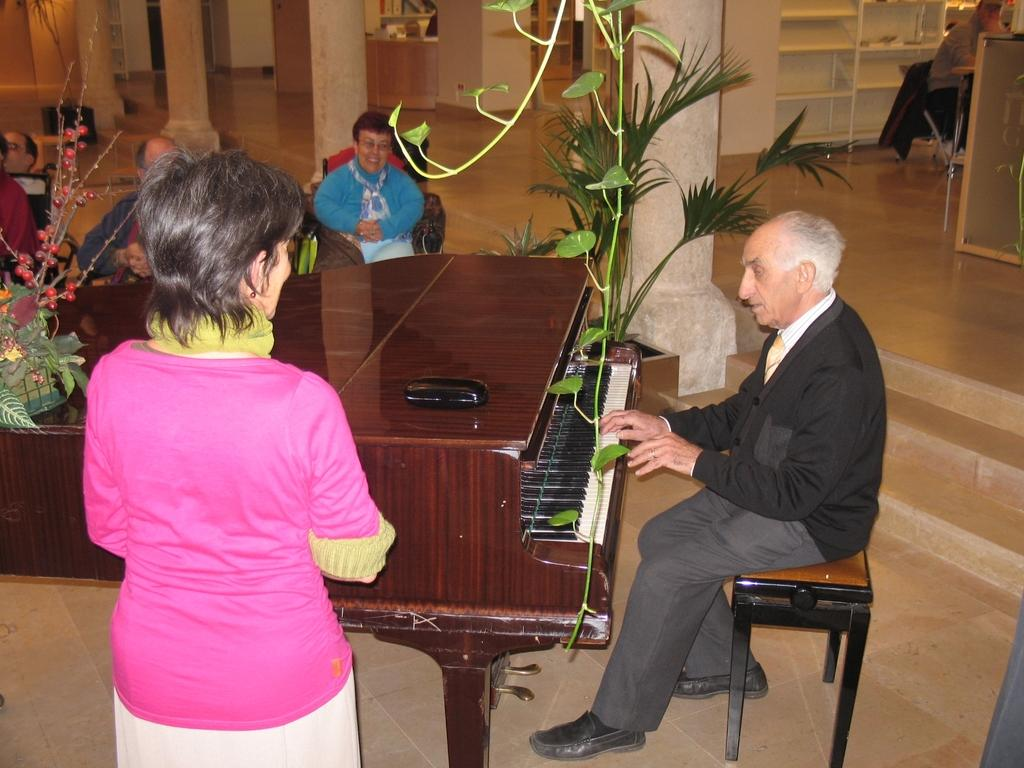What is the main subject of the image? The main subject of the image is a man. What is the man doing in the image? The man is sitting on a chair and playing the piano. What else can be seen in the image besides the man and the piano? There are plants visible in the image. How many cattle are visible in the image? There are no cattle present in the image. What type of shoe is the man wearing in the image? The image does not show the man's shoes, so it cannot be determined from the picture. 